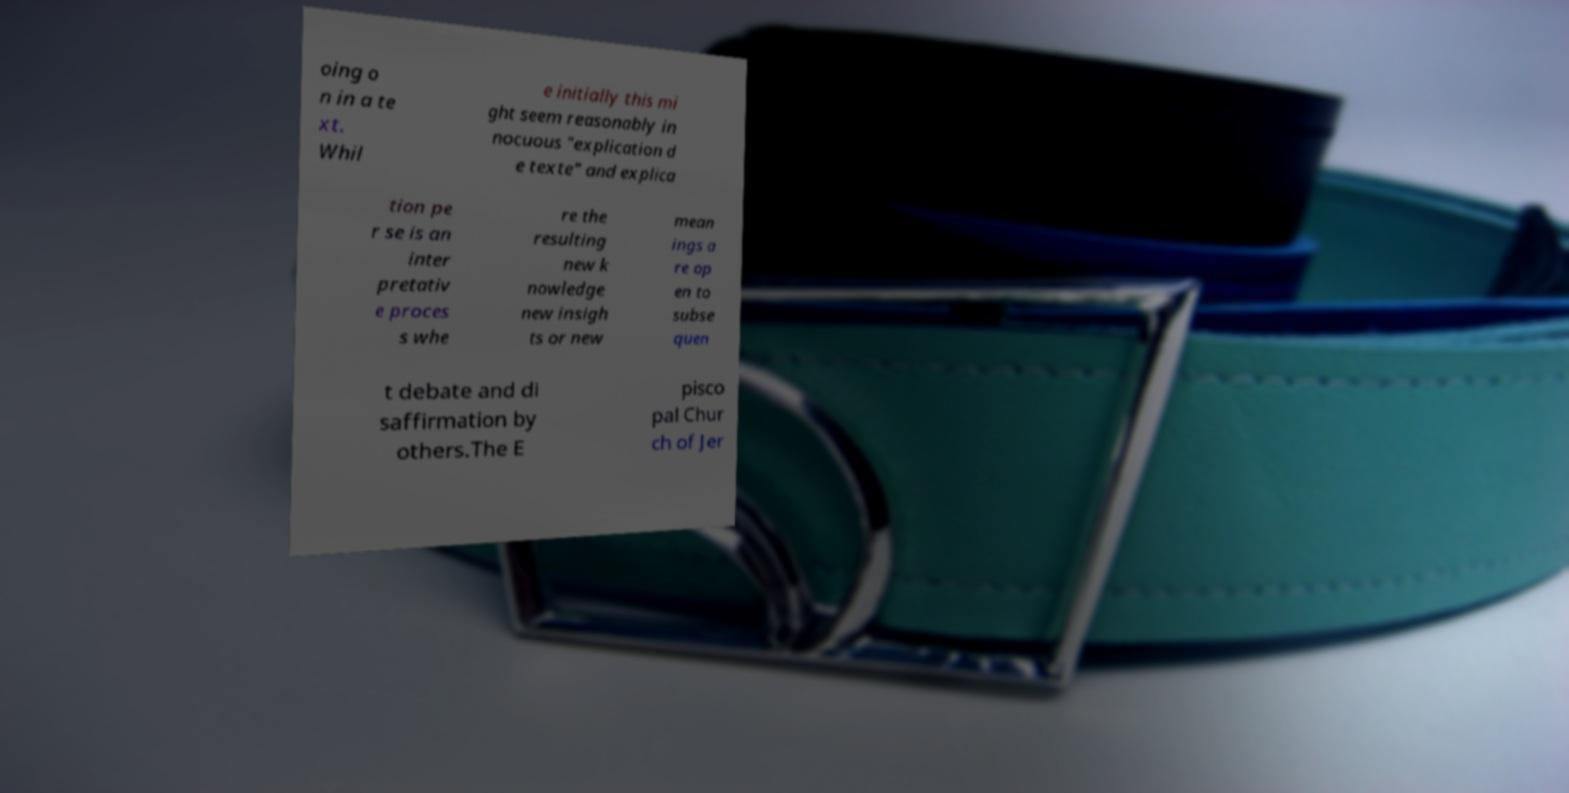I need the written content from this picture converted into text. Can you do that? oing o n in a te xt. Whil e initially this mi ght seem reasonably in nocuous "explication d e texte" and explica tion pe r se is an inter pretativ e proces s whe re the resulting new k nowledge new insigh ts or new mean ings a re op en to subse quen t debate and di saffirmation by others.The E pisco pal Chur ch of Jer 